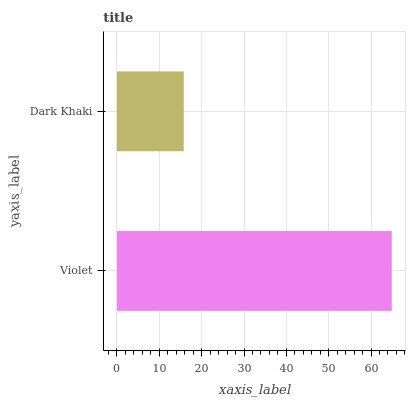Is Dark Khaki the minimum?
Answer yes or no. Yes. Is Violet the maximum?
Answer yes or no. Yes. Is Dark Khaki the maximum?
Answer yes or no. No. Is Violet greater than Dark Khaki?
Answer yes or no. Yes. Is Dark Khaki less than Violet?
Answer yes or no. Yes. Is Dark Khaki greater than Violet?
Answer yes or no. No. Is Violet less than Dark Khaki?
Answer yes or no. No. Is Violet the high median?
Answer yes or no. Yes. Is Dark Khaki the low median?
Answer yes or no. Yes. Is Dark Khaki the high median?
Answer yes or no. No. Is Violet the low median?
Answer yes or no. No. 